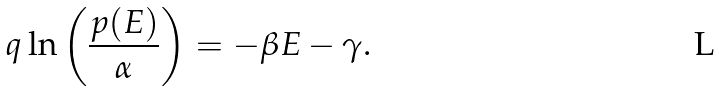Convert formula to latex. <formula><loc_0><loc_0><loc_500><loc_500>\ q \ln \left ( \frac { p ( E ) } { \alpha } \right ) = - \beta E - \gamma .</formula> 